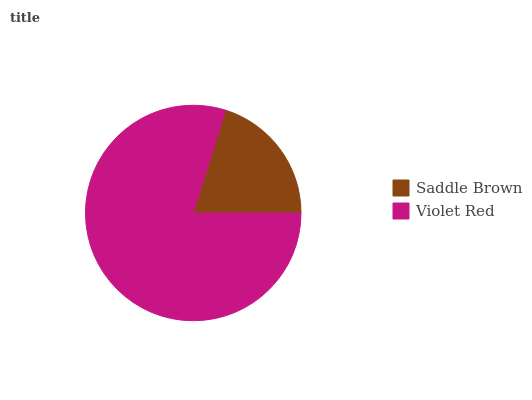Is Saddle Brown the minimum?
Answer yes or no. Yes. Is Violet Red the maximum?
Answer yes or no. Yes. Is Violet Red the minimum?
Answer yes or no. No. Is Violet Red greater than Saddle Brown?
Answer yes or no. Yes. Is Saddle Brown less than Violet Red?
Answer yes or no. Yes. Is Saddle Brown greater than Violet Red?
Answer yes or no. No. Is Violet Red less than Saddle Brown?
Answer yes or no. No. Is Violet Red the high median?
Answer yes or no. Yes. Is Saddle Brown the low median?
Answer yes or no. Yes. Is Saddle Brown the high median?
Answer yes or no. No. Is Violet Red the low median?
Answer yes or no. No. 